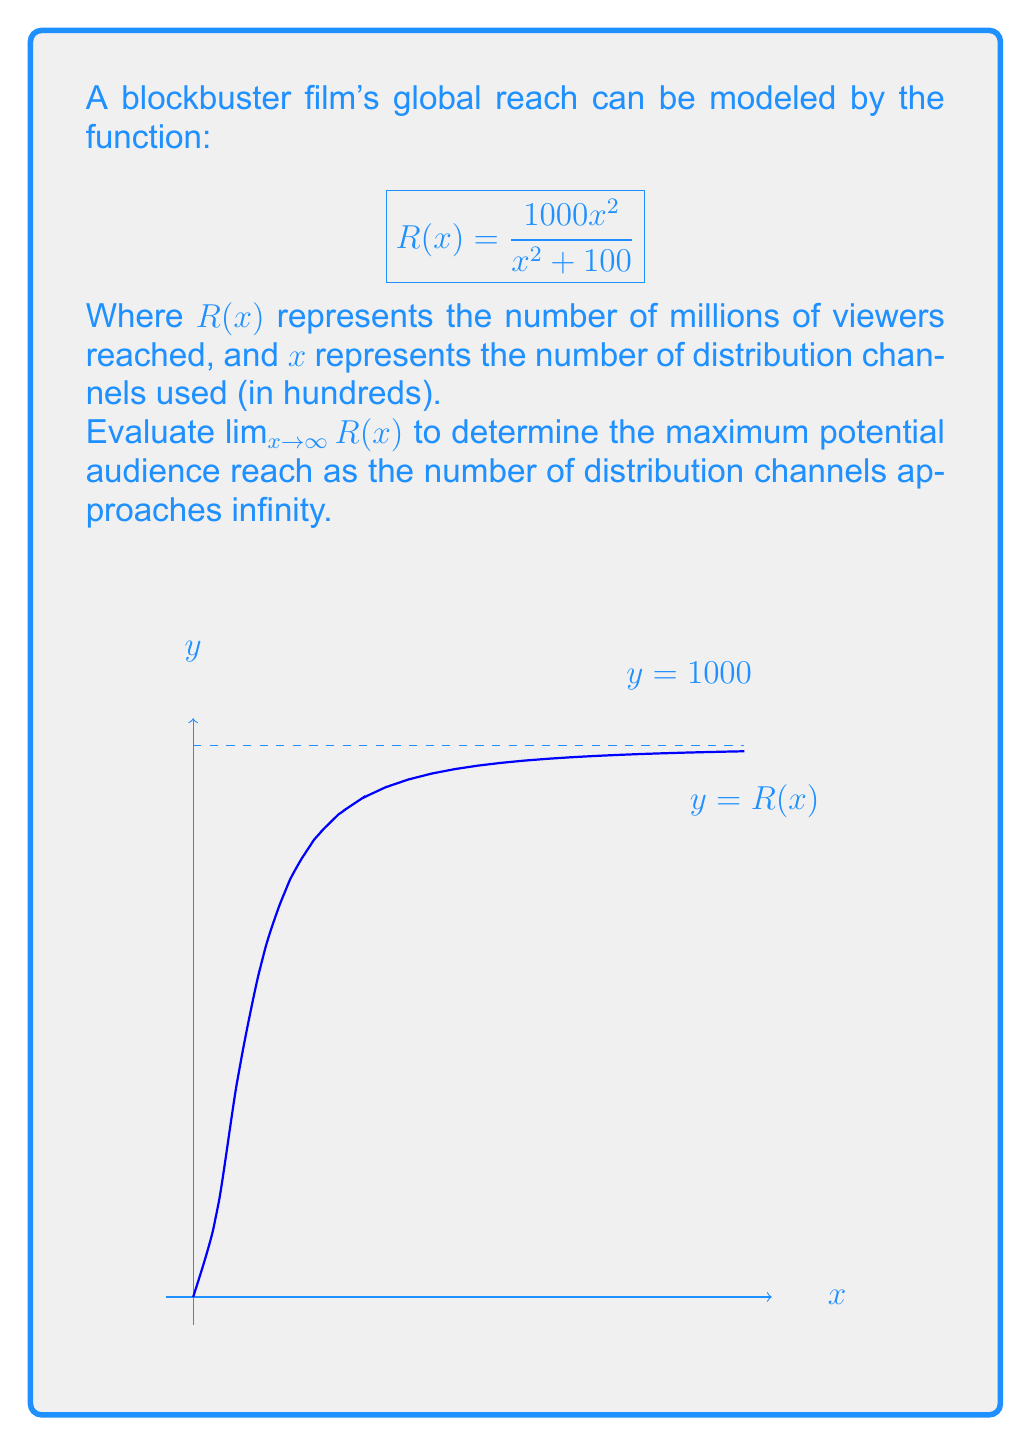Show me your answer to this math problem. Let's approach this step-by-step:

1) We need to evaluate $\lim_{x \to \infty} \frac{1000x^2}{x^2 + 100}$

2) This is an indeterminate form of type $\frac{\infty}{\infty}$, so we can use the method of dividing both numerator and denominator by the highest power of $x$ in the denominator.

3) Divide both numerator and denominator by $x^2$:

   $$\lim_{x \to \infty} \frac{1000x^2}{x^2 + 100} = \lim_{x \to \infty} \frac{1000\frac{x^2}{x^2}}{\frac{x^2}{x^2} + \frac{100}{x^2}}$$

4) Simplify:

   $$\lim_{x \to \infty} \frac{1000}{1 + \frac{100}{x^2}}$$

5) As $x$ approaches infinity, $\frac{100}{x^2}$ approaches 0:

   $$\lim_{x \to \infty} \frac{1000}{1 + 0} = \frac{1000}{1} = 1000$$

Therefore, as the number of distribution channels approaches infinity, the global reach of the film approaches 1000 million viewers.
Answer: $1000$ million viewers 